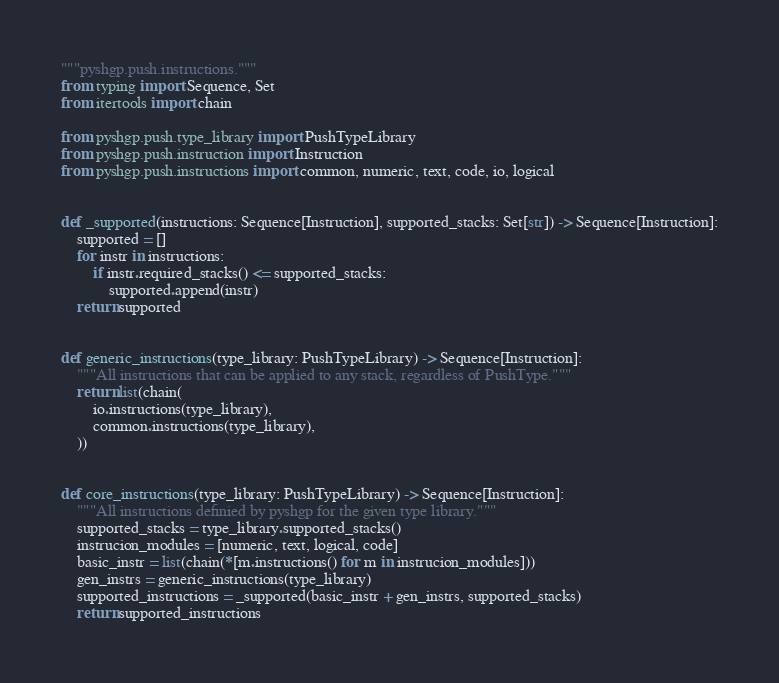Convert code to text. <code><loc_0><loc_0><loc_500><loc_500><_Python_>"""pyshgp.push.instructions."""
from typing import Sequence, Set
from itertools import chain

from pyshgp.push.type_library import PushTypeLibrary
from pyshgp.push.instruction import Instruction
from pyshgp.push.instructions import common, numeric, text, code, io, logical


def _supported(instructions: Sequence[Instruction], supported_stacks: Set[str]) -> Sequence[Instruction]:
    supported = []
    for instr in instructions:
        if instr.required_stacks() <= supported_stacks:
            supported.append(instr)
    return supported


def generic_instructions(type_library: PushTypeLibrary) -> Sequence[Instruction]:
    """All instructions that can be applied to any stack, regardless of PushType."""
    return list(chain(
        io.instructions(type_library),
        common.instructions(type_library),
    ))


def core_instructions(type_library: PushTypeLibrary) -> Sequence[Instruction]:
    """All instructions definied by pyshgp for the given type library."""
    supported_stacks = type_library.supported_stacks()
    instrucion_modules = [numeric, text, logical, code]
    basic_instr = list(chain(*[m.instructions() for m in instrucion_modules]))
    gen_instrs = generic_instructions(type_library)
    supported_instructions = _supported(basic_instr + gen_instrs, supported_stacks)
    return supported_instructions
</code> 